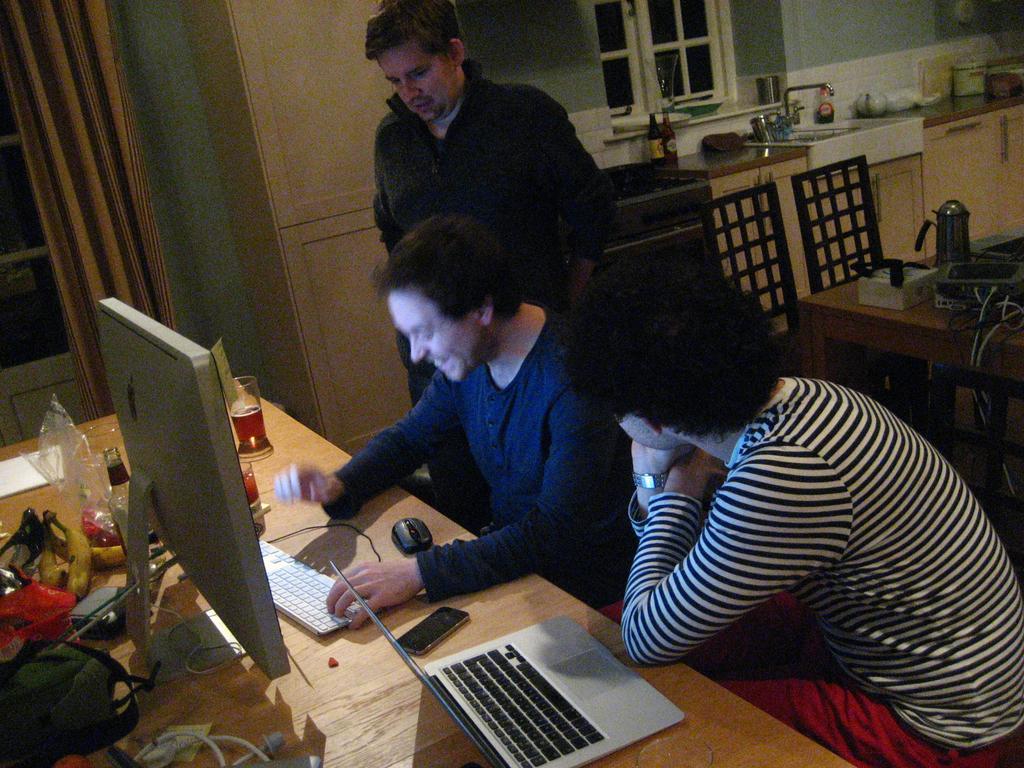Please provide a concise description of this image. In this image I can see three people. Two people are sitting in front of the table and one person is standing. On the table there is a glass,system,laptop,mobile and some of the objects. At the back there is a countertop and the sink. 